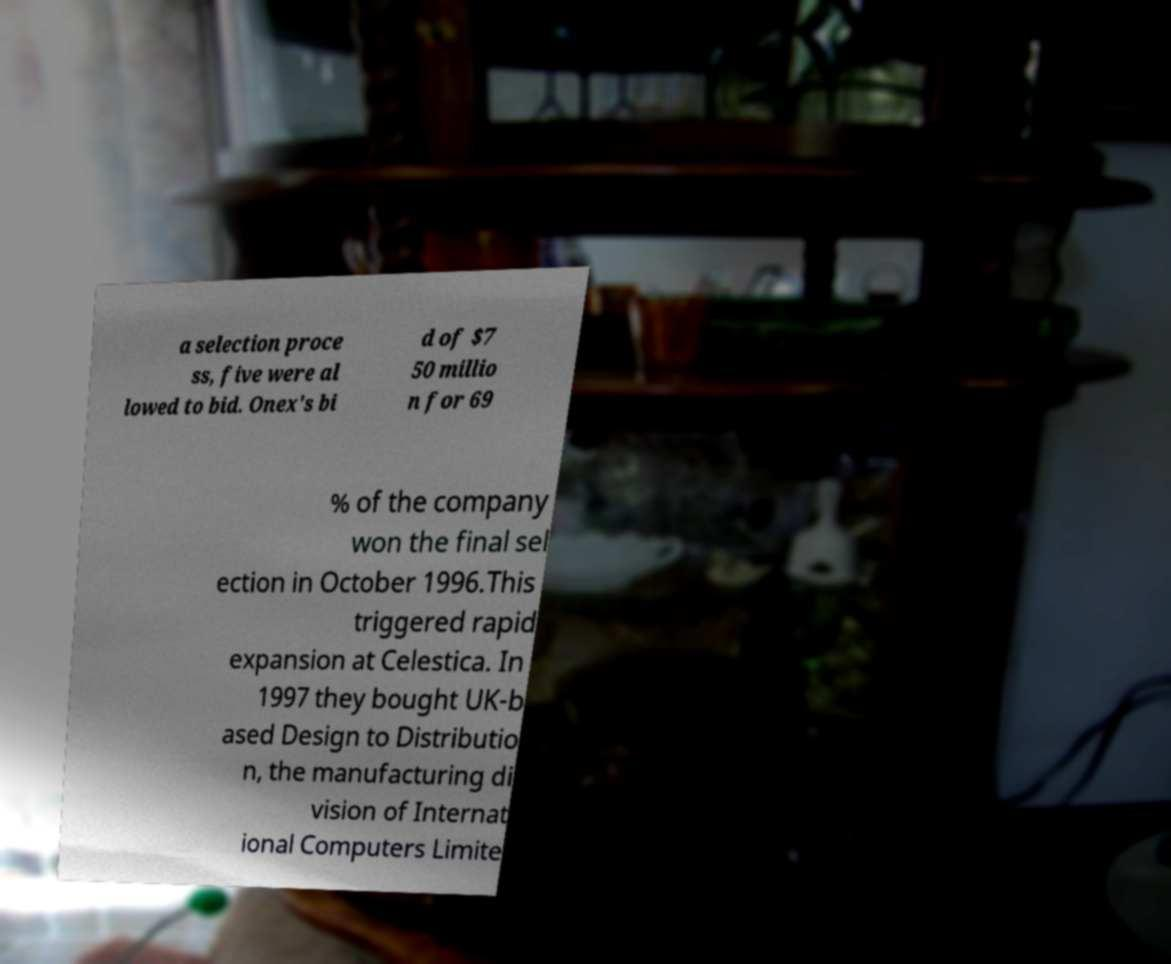Please read and relay the text visible in this image. What does it say? a selection proce ss, five were al lowed to bid. Onex's bi d of $7 50 millio n for 69 % of the company won the final sel ection in October 1996.This triggered rapid expansion at Celestica. In 1997 they bought UK-b ased Design to Distributio n, the manufacturing di vision of Internat ional Computers Limite 